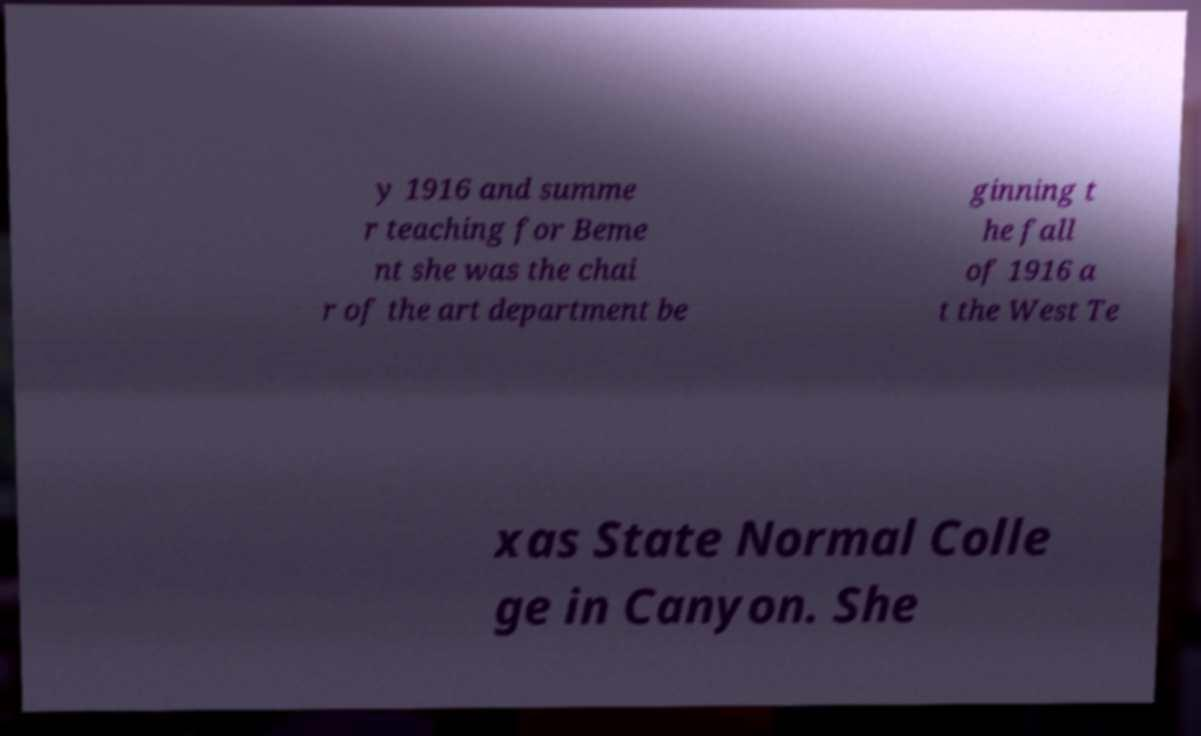I need the written content from this picture converted into text. Can you do that? y 1916 and summe r teaching for Beme nt she was the chai r of the art department be ginning t he fall of 1916 a t the West Te xas State Normal Colle ge in Canyon. She 